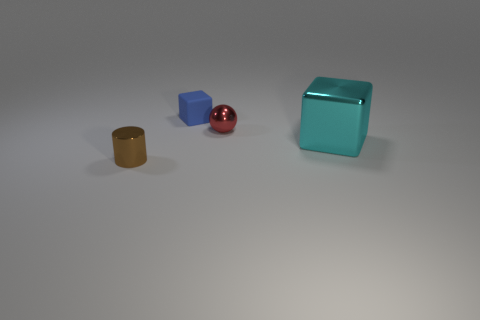There is a ball; does it have the same color as the cube on the left side of the large metal object?
Provide a succinct answer. No. What color is the shiny cube?
Your response must be concise. Cyan. What number of objects are either big gray objects or small brown cylinders?
Ensure brevity in your answer.  1. There is a blue thing that is the same size as the cylinder; what is its material?
Make the answer very short. Rubber. There is a object in front of the cyan thing; what size is it?
Your response must be concise. Small. What is the big cyan cube made of?
Your answer should be very brief. Metal. How many things are small metallic objects that are behind the tiny brown shiny object or metallic objects in front of the tiny red shiny ball?
Give a very brief answer. 3. There is a red shiny thing; is its shape the same as the tiny object that is in front of the small red metallic object?
Your answer should be very brief. No. Are there fewer blocks that are in front of the blue rubber thing than blue cubes to the right of the tiny brown metal object?
Ensure brevity in your answer.  No. What material is the other small object that is the same shape as the cyan thing?
Ensure brevity in your answer.  Rubber. 